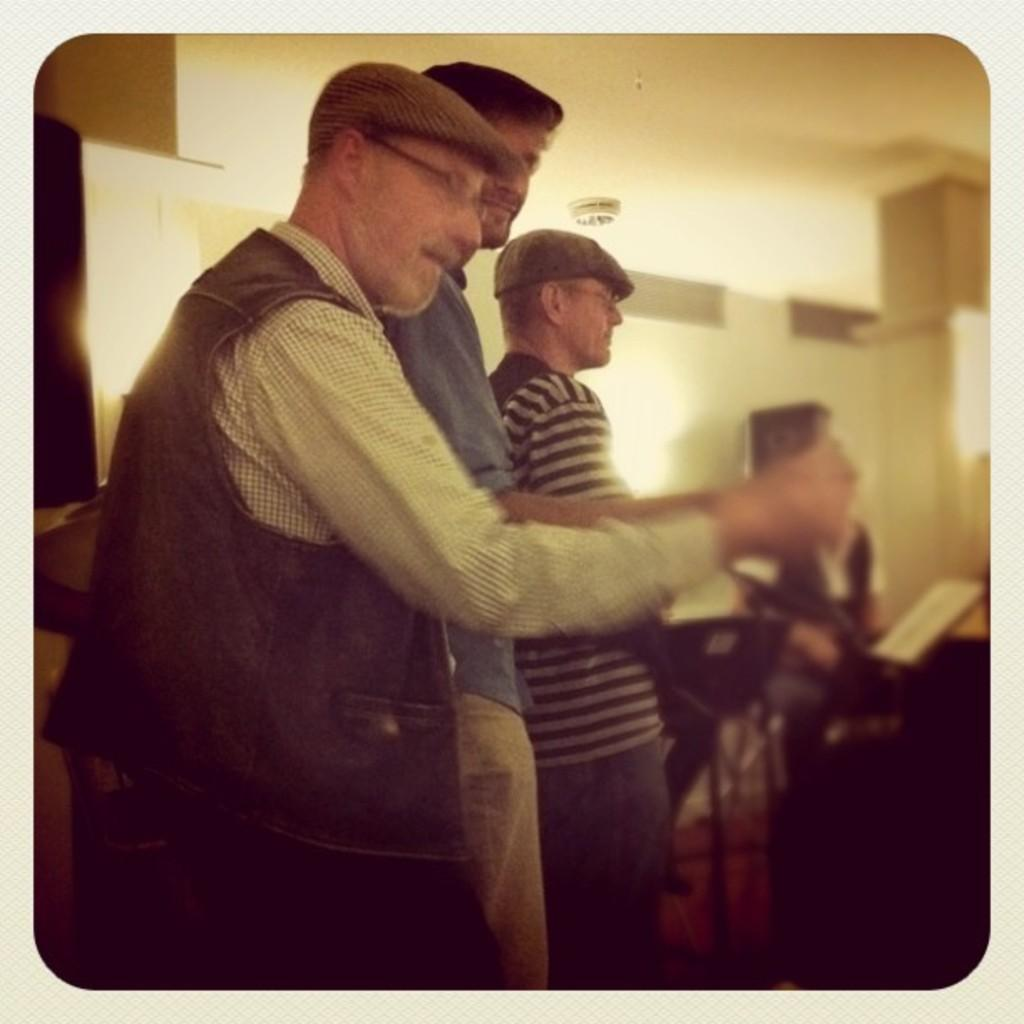What is happening in the image? There are people standing in the image. What are the people wearing? The people are wearing clothes. Can you describe any specific accessories the people are wearing? Two of the people are wearing spectacles, and two are wearing caps. How would you describe the background of the image? The background of the image is blurred. How many bushes can be seen growing in the image? There are no bushes visible in the image; it features people standing with a blurred background. 